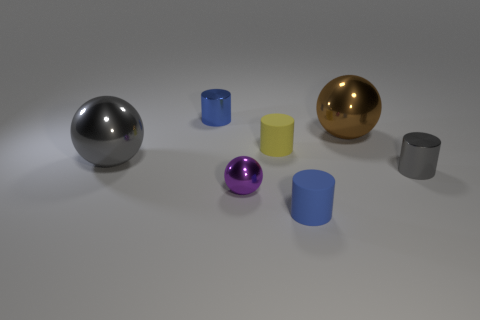Is there a purple thing?
Provide a short and direct response. Yes. What is the color of the small metal thing behind the gray cylinder?
Provide a short and direct response. Blue. There is a purple metal sphere; does it have the same size as the gray object that is on the right side of the blue metallic cylinder?
Your answer should be very brief. Yes. There is a thing that is both on the right side of the purple sphere and in front of the gray shiny cylinder; how big is it?
Your answer should be compact. Small. Is there a tiny gray cylinder made of the same material as the small yellow cylinder?
Provide a succinct answer. No. The big brown object has what shape?
Provide a short and direct response. Sphere. Do the gray ball and the blue rubber thing have the same size?
Keep it short and to the point. No. How many other objects are the same shape as the large brown thing?
Make the answer very short. 2. The small shiny object behind the gray shiny cylinder has what shape?
Make the answer very short. Cylinder. There is a big metallic thing that is right of the blue rubber cylinder; does it have the same shape as the blue object in front of the blue metal cylinder?
Provide a succinct answer. No. 